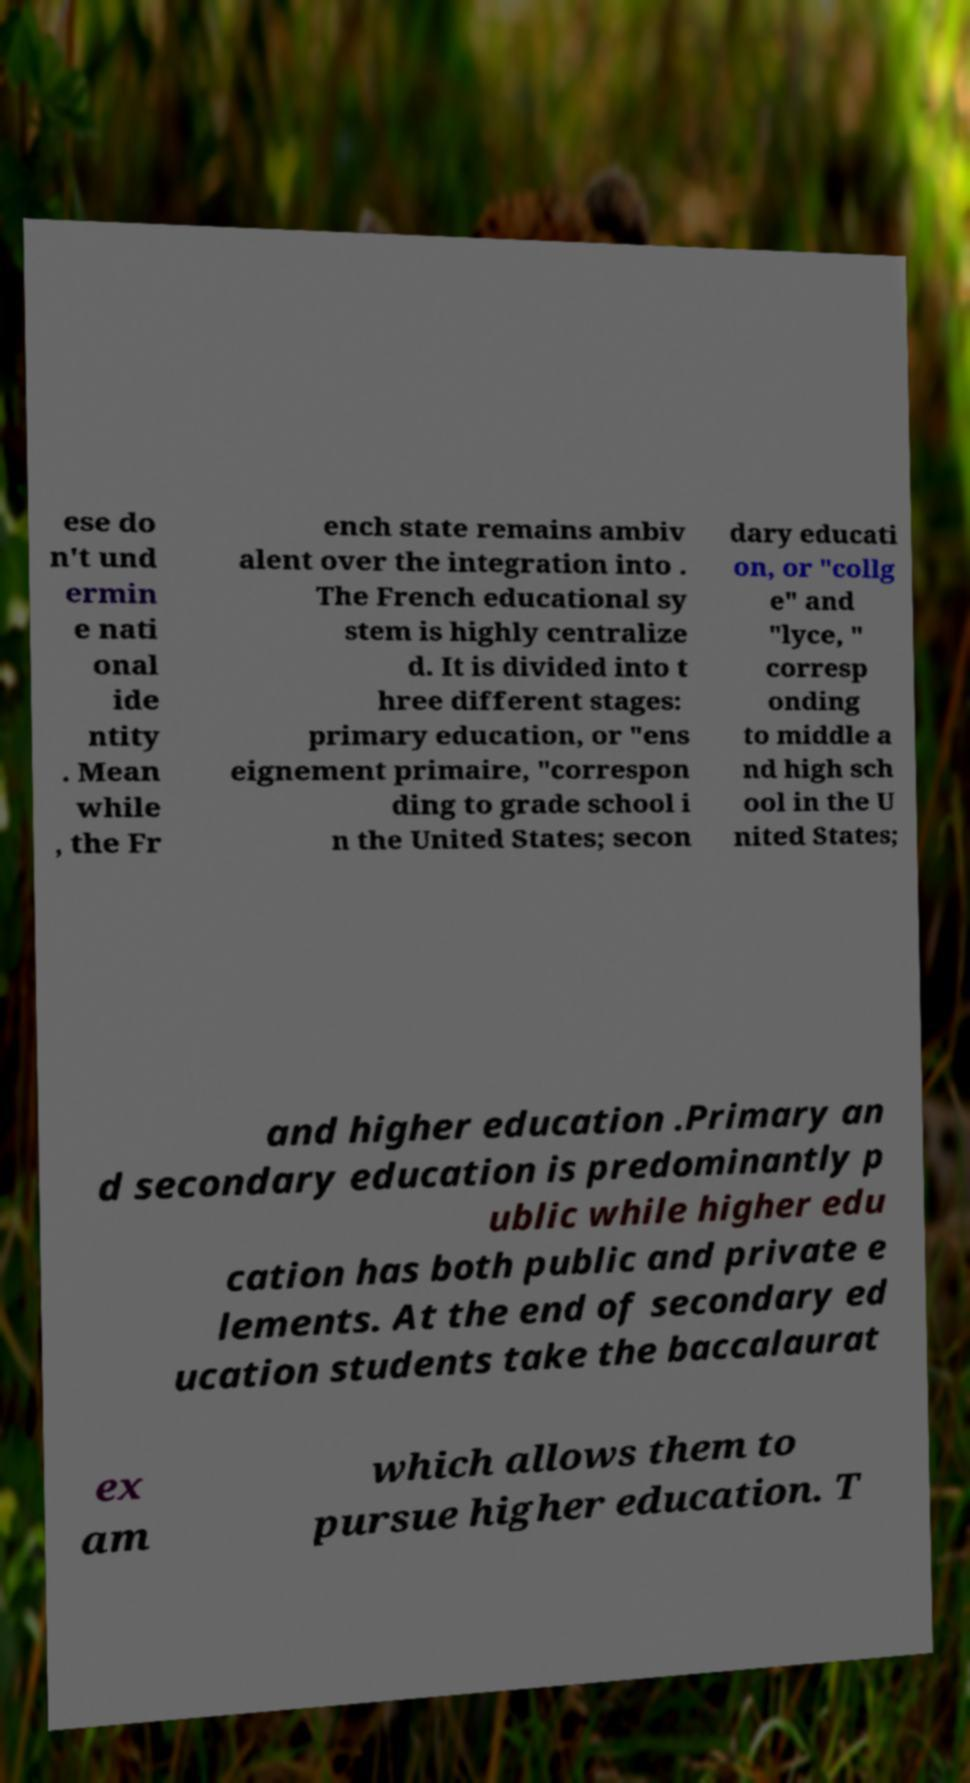What messages or text are displayed in this image? I need them in a readable, typed format. ese do n't und ermin e nati onal ide ntity . Mean while , the Fr ench state remains ambiv alent over the integration into . The French educational sy stem is highly centralize d. It is divided into t hree different stages: primary education, or "ens eignement primaire, "correspon ding to grade school i n the United States; secon dary educati on, or "collg e" and "lyce, " corresp onding to middle a nd high sch ool in the U nited States; and higher education .Primary an d secondary education is predominantly p ublic while higher edu cation has both public and private e lements. At the end of secondary ed ucation students take the baccalaurat ex am which allows them to pursue higher education. T 